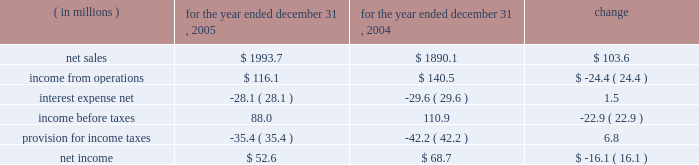Incentive compensation expense ( $ 8.2 million ) and related fringe benefit costs ( $ 1.4 million ) , and higher warehousing costs due to customer requirements ( $ 2.0 million ) .
Corporate overhead for the year ended december 31 , 2006 , increased $ 3.1 million , or 6.5% ( 6.5 % ) , from the year ended december 31 , 2005 .
The increase was primarily attributable to higher incentive compensation expense ( $ 2.6 million ) and other increased costs which were not individually significant .
Other expense , net , decreased $ 2.1 million , or 20.1% ( 20.1 % ) for the year ended december 31 , 2006 compared to the year ended december 31 , 2005 .
The decrease was primarily due to a $ 3.1 million decrease in expenses related to the disposals of property , plant and equipment as part of planned disposals in connection with capital projects .
Partially offsetting the decrease in fixed asset disposal expense was higher legal expenses ( $ 0.5 million ) and increased losses on disposals of storeroom items ( $ 0.4 million ) .
Interest expense , net and income taxes interest expense , net of interest income , increased by $ 3.1 million , or 11.1% ( 11.1 % ) , for the year ended december 31 , 2006 compared to the full year 2005 , primarily as a result of higher interest expense on our variable rate debt due to higher interest rates .
Pca 2019s effective tax rate was 35.8% ( 35.8 % ) for the year ended december 31 , 2006 and 40.2% ( 40.2 % ) for the year ended december 31 , 2005 .
The lower tax rate in 2006 is primarily due to a larger domestic manufacturer 2019s deduction and a reduction in the texas state tax rate .
For both years 2006 and 2005 , tax rates were higher than the federal statutory rate of 35.0% ( 35.0 % ) due to state income taxes .
Year ended december 31 , 2005 compared to year ended december 31 , 2004 the historical results of operations of pca for the years ended december 31 , 2005 and 2004 are set forth below : for the year ended december 31 , ( in millions ) 2005 2004 change .
Net sales net sales increased by $ 103.6 million , or 5.5% ( 5.5 % ) , for the year ended december 31 , 2005 from the year ended december 31 , 2004 .
Net sales increased primarily due to increased sales prices and volumes of corrugated products compared to 2004 .
Total corrugated products volume sold increased 4.2% ( 4.2 % ) to 31.2 billion square feet in 2005 compared to 29.9 billion square feet in 2004 .
On a comparable shipment-per-workday basis , corrugated products sales volume increased 4.6% ( 4.6 % ) in 2005 from 2004 .
Excluding pca 2019s acquisition of midland container in april 2005 , corrugated products volume was 3.0% ( 3.0 % ) higher in 2005 than 2004 and up 3.4% ( 3.4 % ) compared to 2004 on a shipment-per-workday basis .
Shipments-per-workday is calculated by dividing our total corrugated products volume during the year by the number of workdays within the year .
The larger percentage increase was due to the fact that 2005 had one less workday ( 250 days ) , those days not falling on a weekend or holiday , than 2004 ( 251 days ) .
Containerboard sales volume to external domestic and export customers decreased 12.2% ( 12.2 % ) to 417000 tons for the year ended december 31 , 2005 from 475000 tons in 2004. .
What was the operating margin for 2005? 
Computations: (116.1 / 1993.7)
Answer: 0.05823. 